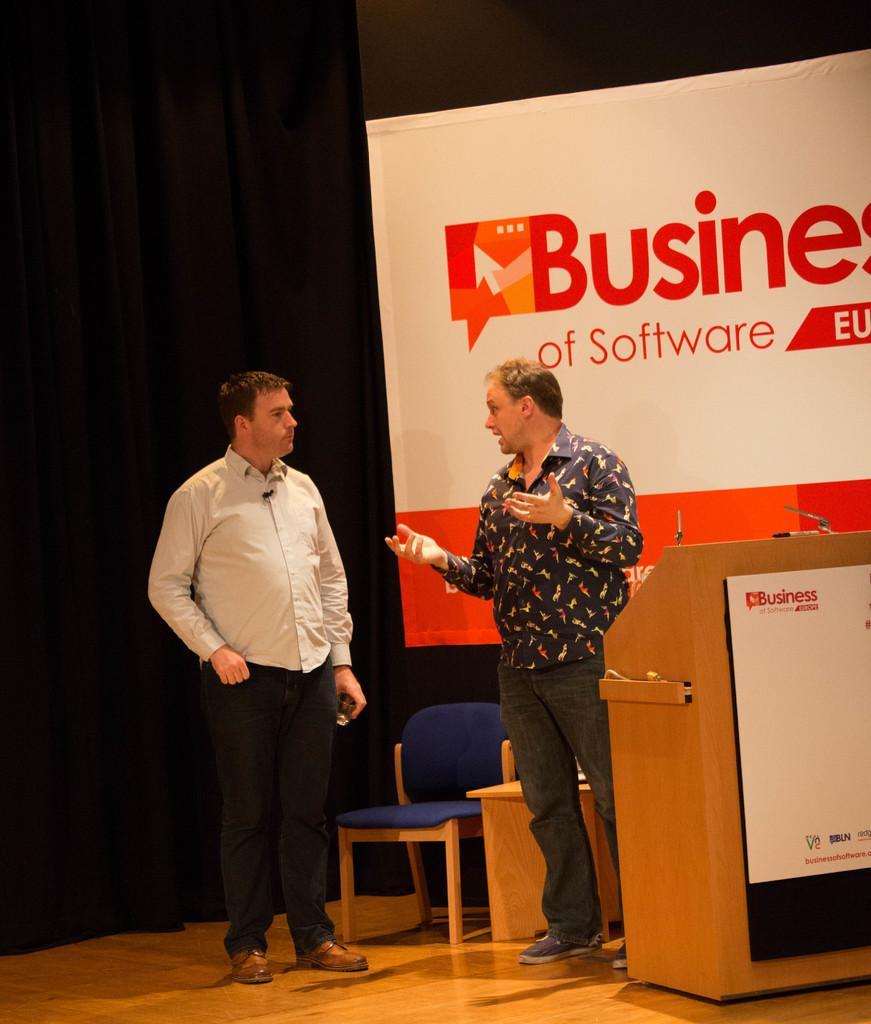Can you describe this image briefly? In the image we can see there are two men who are standing. 